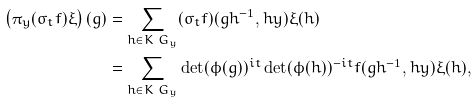<formula> <loc_0><loc_0><loc_500><loc_500>\left ( \pi _ { y } ( \sigma _ { t } f ) \xi \right ) ( g ) & = \sum _ { h \in K \ G _ { y } } ( \sigma _ { t } f ) ( g h ^ { - 1 } , h y ) \xi ( h ) \\ & = \sum _ { h \in K \ G _ { y } } \det ( \phi ( g ) ) ^ { i t } \det ( \phi ( h ) ) ^ { - i t } f ( g h ^ { - 1 } , h y ) \xi ( h ) ,</formula> 